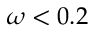<formula> <loc_0><loc_0><loc_500><loc_500>\omega < 0 . 2</formula> 